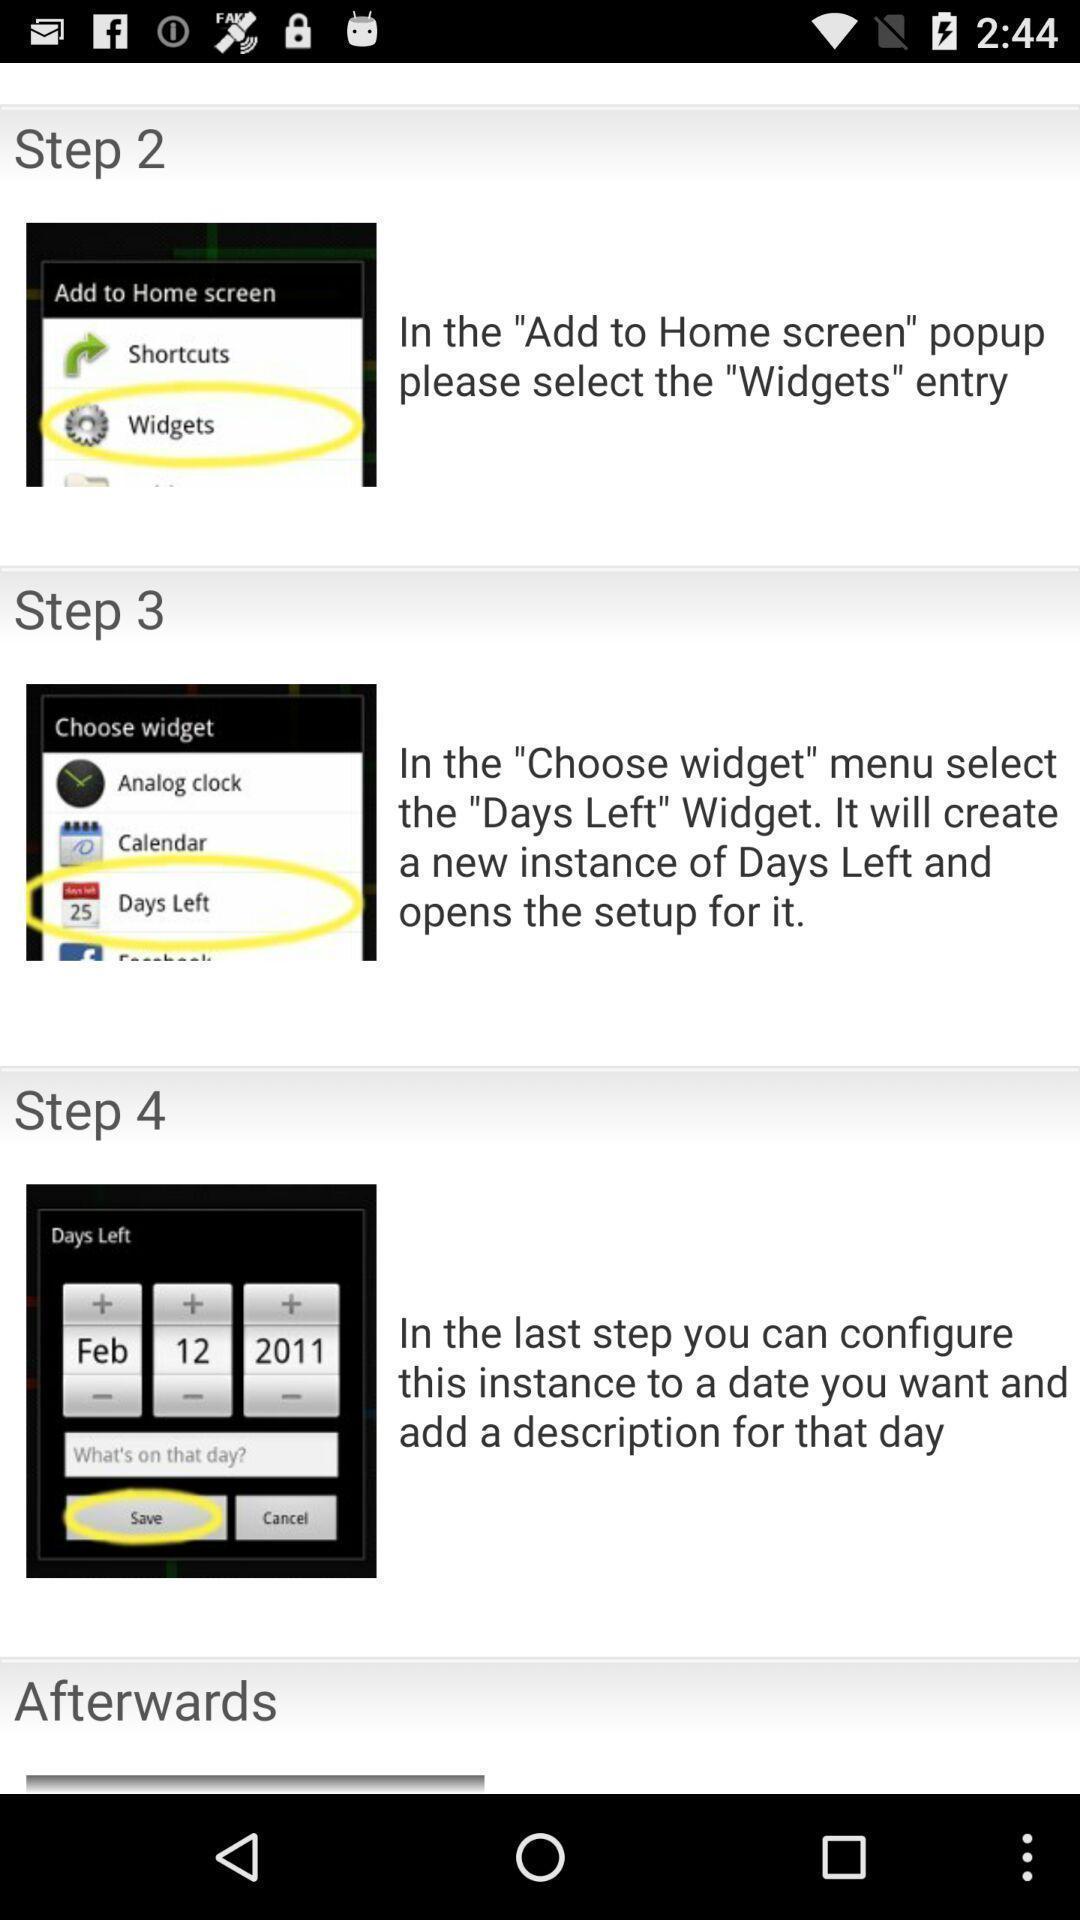Provide a detailed account of this screenshot. Step by step instructions. 